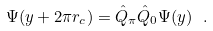Convert formula to latex. <formula><loc_0><loc_0><loc_500><loc_500>\Psi ( y + 2 \pi r _ { c } ) = { \hat { Q } } _ { \pi } { \hat { Q } } _ { 0 } \Psi ( y ) \ .</formula> 